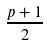<formula> <loc_0><loc_0><loc_500><loc_500>\frac { p + 1 } { 2 }</formula> 